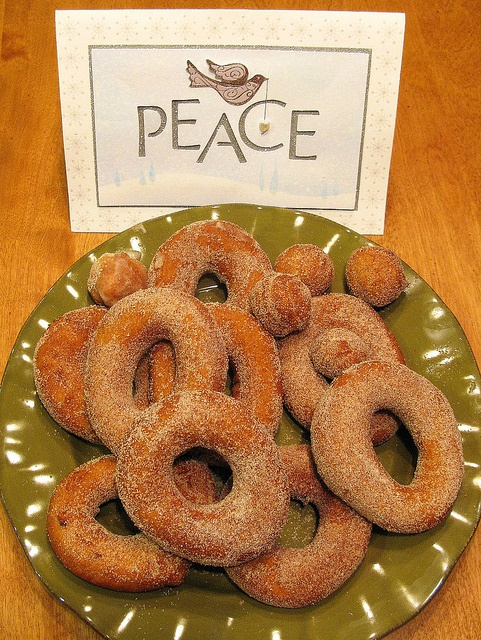Describe the objects in this image and their specific colors. I can see donut in orange, brown, tan, maroon, and salmon tones, donut in orange, tan, brown, maroon, and salmon tones, donut in orange, brown, tan, red, and salmon tones, donut in orange, brown, maroon, and red tones, and donut in orange, brown, maroon, tan, and red tones in this image. 